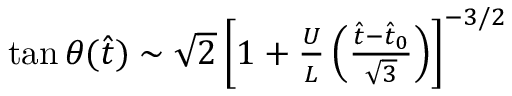<formula> <loc_0><loc_0><loc_500><loc_500>\begin{array} { r } { \tan \theta ( \hat { t } ) \sim \sqrt { 2 } \left [ 1 + \frac { U } { L } \left ( \frac { \hat { t } - \hat { t } _ { 0 } } { \sqrt { 3 } } \right ) \right ] ^ { - 3 / 2 } } \end{array}</formula> 